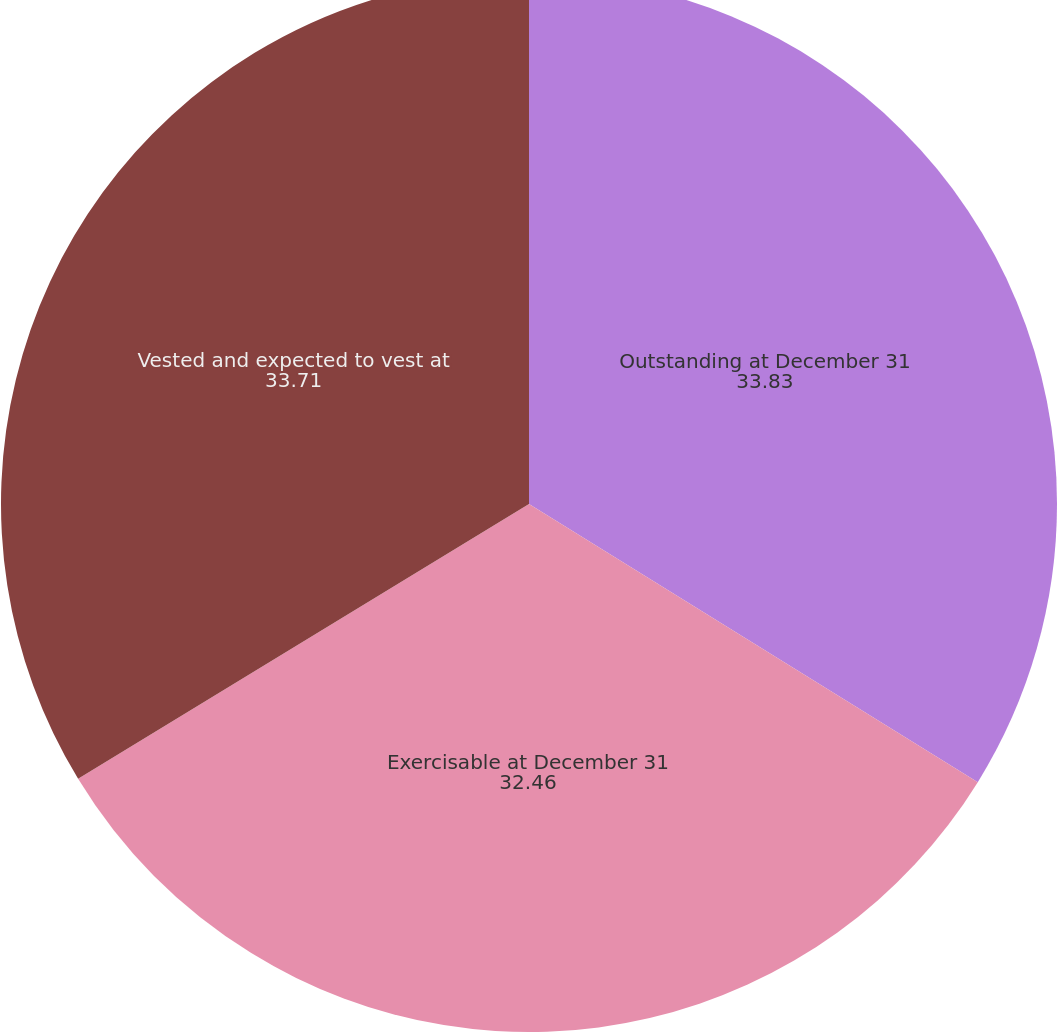Convert chart to OTSL. <chart><loc_0><loc_0><loc_500><loc_500><pie_chart><fcel>Outstanding at December 31<fcel>Exercisable at December 31<fcel>Vested and expected to vest at<nl><fcel>33.83%<fcel>32.46%<fcel>33.71%<nl></chart> 